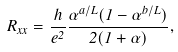Convert formula to latex. <formula><loc_0><loc_0><loc_500><loc_500>R _ { x x } = \frac { h } { e ^ { 2 } } \frac { \alpha ^ { a / L } ( 1 - \alpha ^ { b / L } ) } { 2 ( 1 + \alpha ) } ,</formula> 